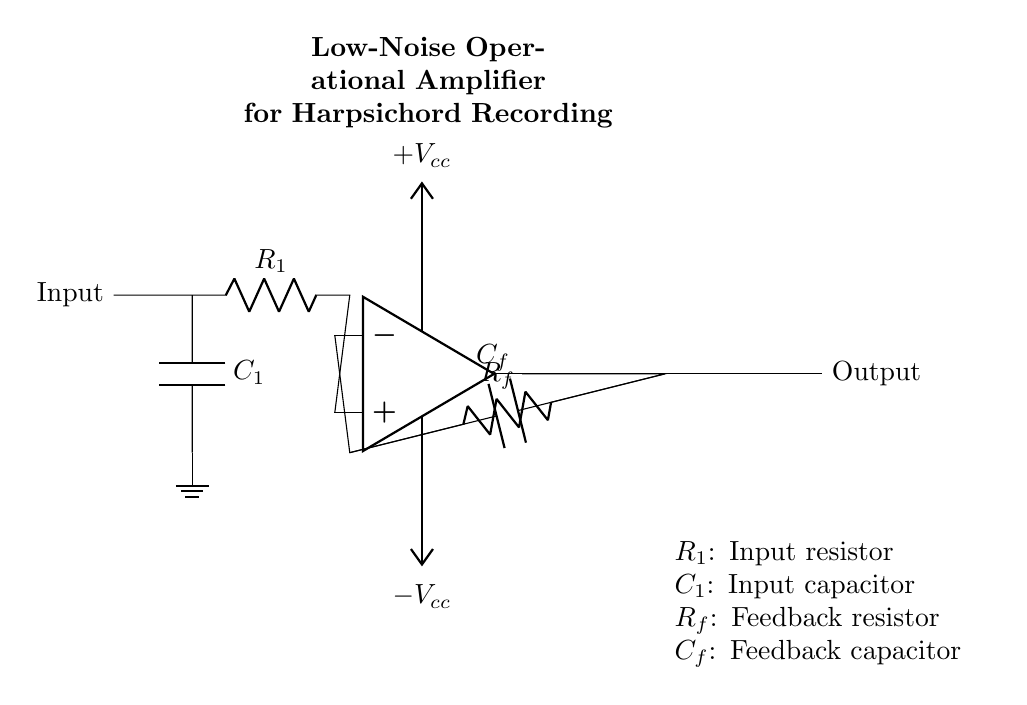What is the type of operational amplifier used in this circuit? The circuit specifies a low-noise operational amplifier designed for sensitive applications, which is indicated in the label.
Answer: Low-noise operational amplifier What is the purpose of the input capacitor? The input capacitor is used to block any DC offsets from the signal source, allowing only AC signals (the audio frequencies) to pass through to the amplifier.
Answer: Block DC offsets What is the value of the feedback resistor denoted in the diagram? In the circuit, the feedback resistor is labeled as R_f. While the exact value isn't specified in the diagram, it is crucial for setting the gain of the op-amp.
Answer: R_f How does the feedback capacitor affect the circuit? The feedback capacitor, C_f, adds a frequency-dependent behavior that affects the stability and bandwidth of the amplifier by providing feedback at certain frequencies to prevent oscillations.
Answer: Affects stability and bandwidth What are the power supply voltages indicated in the circuit? The circuit shows two power supply voltages: one labeled as V_cc for the positive voltage supply and one labeled as V_ee for the negative voltage supply.
Answer: Plus V_cc and minus V_cc 